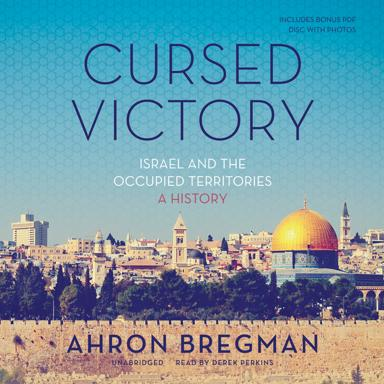Can you describe the visual theme and aesthetic of the cover image? The cover features a panoramic view of Jerusalem, highlighting iconic landmarks like the Dome of the Rock. The design uses a bright, warm color palette, which reflects the vibrant and historical ambiance of the region. The title is overlayed with a modern, slightly distressed typographic style, suggesting the complex and contentious history of the territories. 